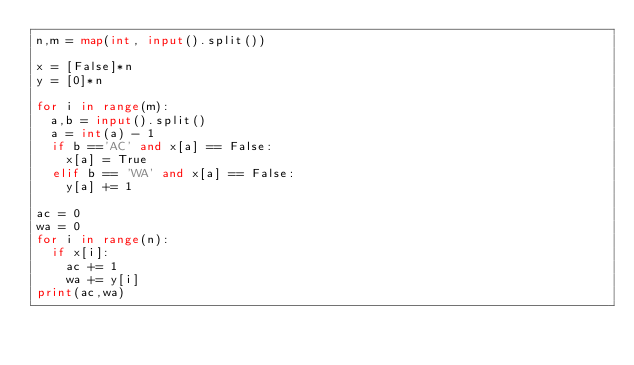Convert code to text. <code><loc_0><loc_0><loc_500><loc_500><_Python_>n,m = map(int, input().split())

x = [False]*n
y = [0]*n

for i in range(m):
  a,b = input().split()
  a = int(a) - 1
  if b =='AC' and x[a] == False:
    x[a] = True
  elif b == 'WA' and x[a] == False:
    y[a] += 1

ac = 0
wa = 0
for i in range(n):
  if x[i]:
    ac += 1
    wa += y[i]
print(ac,wa)</code> 